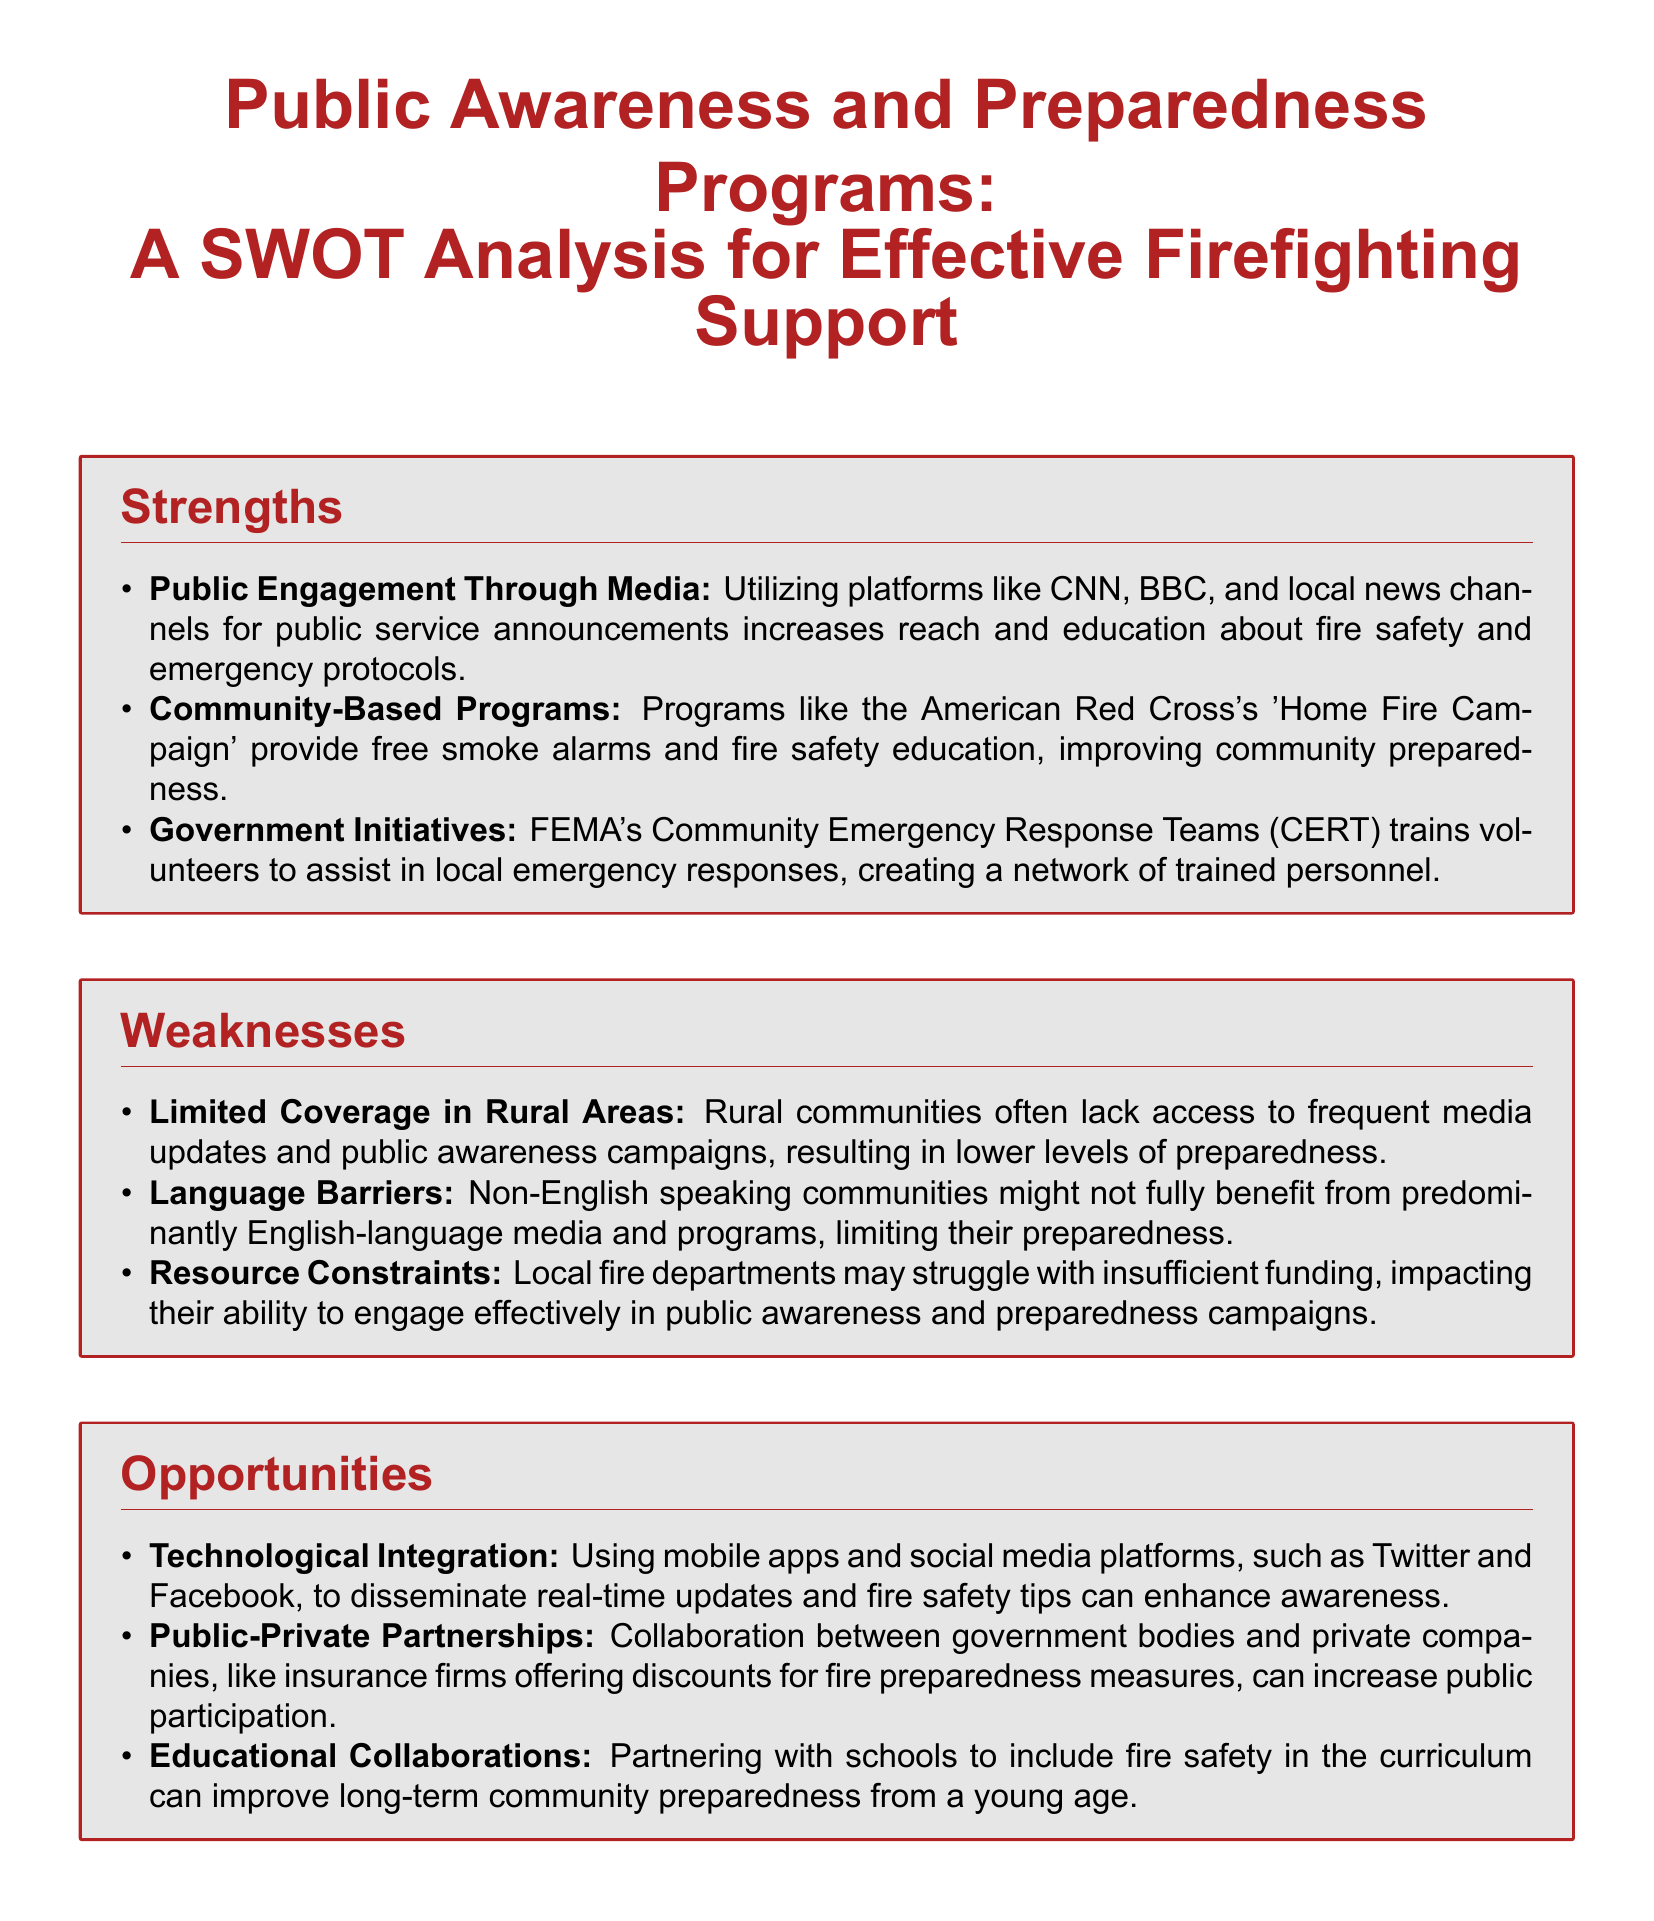What is one strength of public awareness programs? The strength mentioned is using media platforms like CNN, BBC, and local news channels for public service announcements to increase reach and education about fire safety.
Answer: Public Engagement Through Media What is a weakness related to community demographics? The document highlights that non-English speaking communities might not benefit from predominantly English-language media and programs.
Answer: Language Barriers What is one opportunity mentioned for public awareness programs? The analysis suggests that leveraging mobile apps and social media for real-time updates and fire safety tips can enhance awareness.
Answer: Technological Integration What threat is associated with misinformation? The threat specified is that the spread of incorrect information on social media can undermine public trust and preparedness efforts.
Answer: Misinformation and Fake News How does the document categorize strengths, weaknesses, opportunities, and threats? The document analyzes these aspects in a SWOT framework, which stands for Strengths, Weaknesses, Opportunities, and Threats.
Answer: SWOT analysis What initiative helps in training volunteers for local emergency responses? The document mentions FEMA's Community Emergency Response Teams (CERT) as a program that trains volunteers.
Answer: Community Emergency Response Teams What impact does climate change have according to the document? Climate change is noted to increase the frequency and severity of wildfires, which can overwhelm current preparedness efforts.
Answer: Climate Change How can public-private partnerships enhance preparedness? The document states that collaboration with private companies, like insurance firms offering discounts, can increase public participation.
Answer: Public-Private Partnerships 